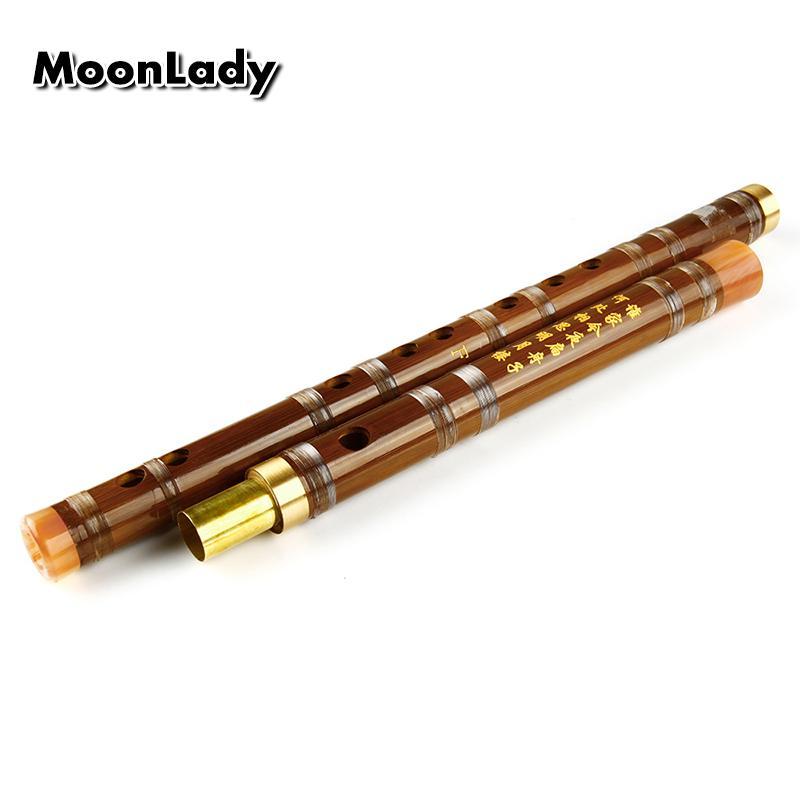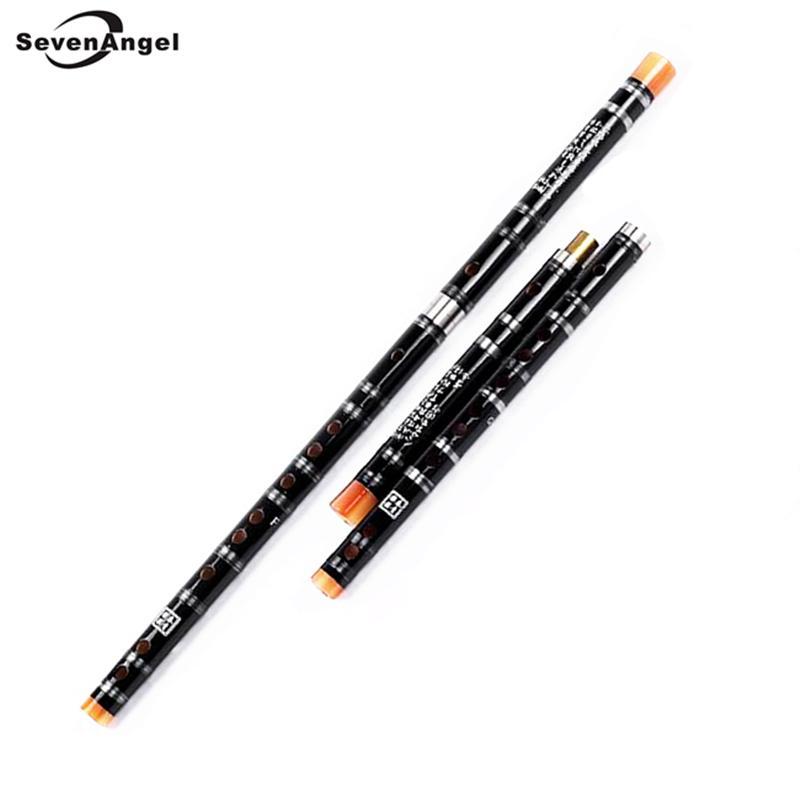The first image is the image on the left, the second image is the image on the right. Evaluate the accuracy of this statement regarding the images: "The left image shows two flutes side-by-side, displayed diagonally with ends at the upper right.". Is it true? Answer yes or no. Yes. 